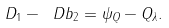Convert formula to latex. <formula><loc_0><loc_0><loc_500><loc_500>D _ { 1 } - \ D b _ { 2 } = \psi _ { Q } - Q _ { \lambda } .</formula> 